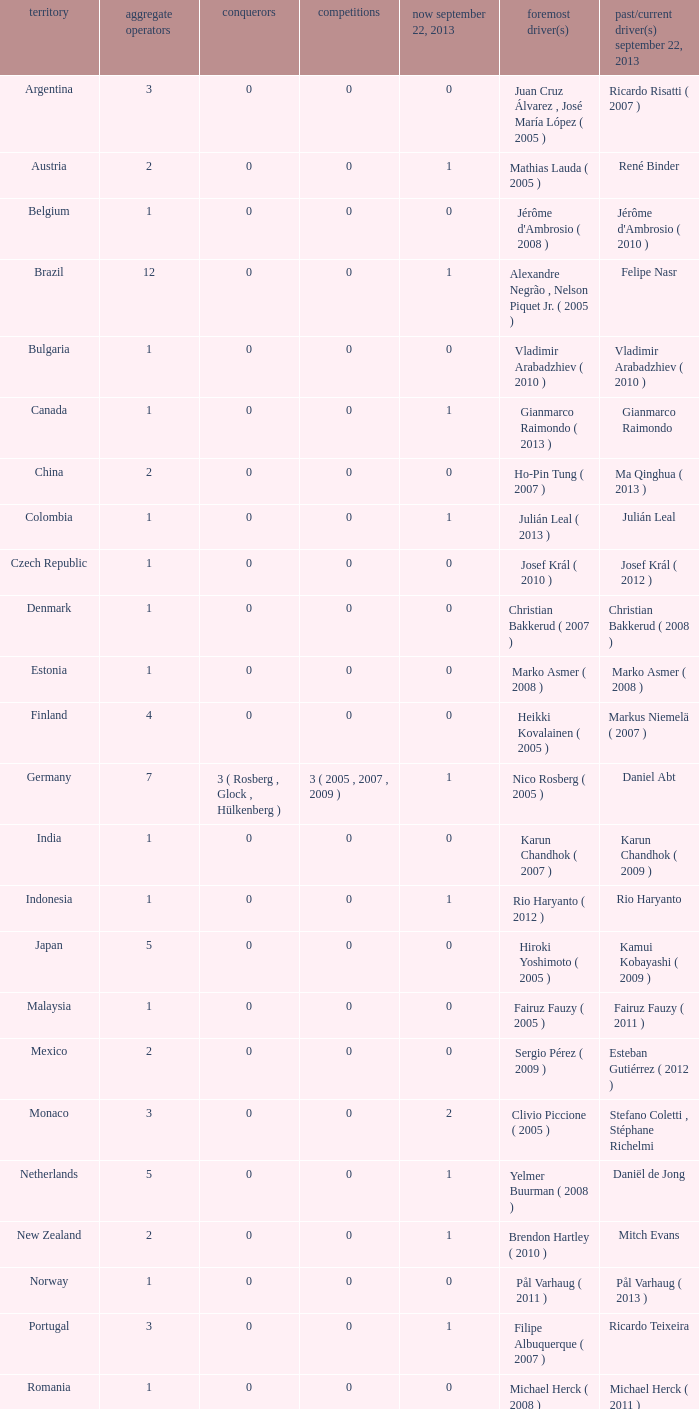How many champions were there when the last driver for September 22, 2013 was vladimir arabadzhiev ( 2010 )? 0.0. 